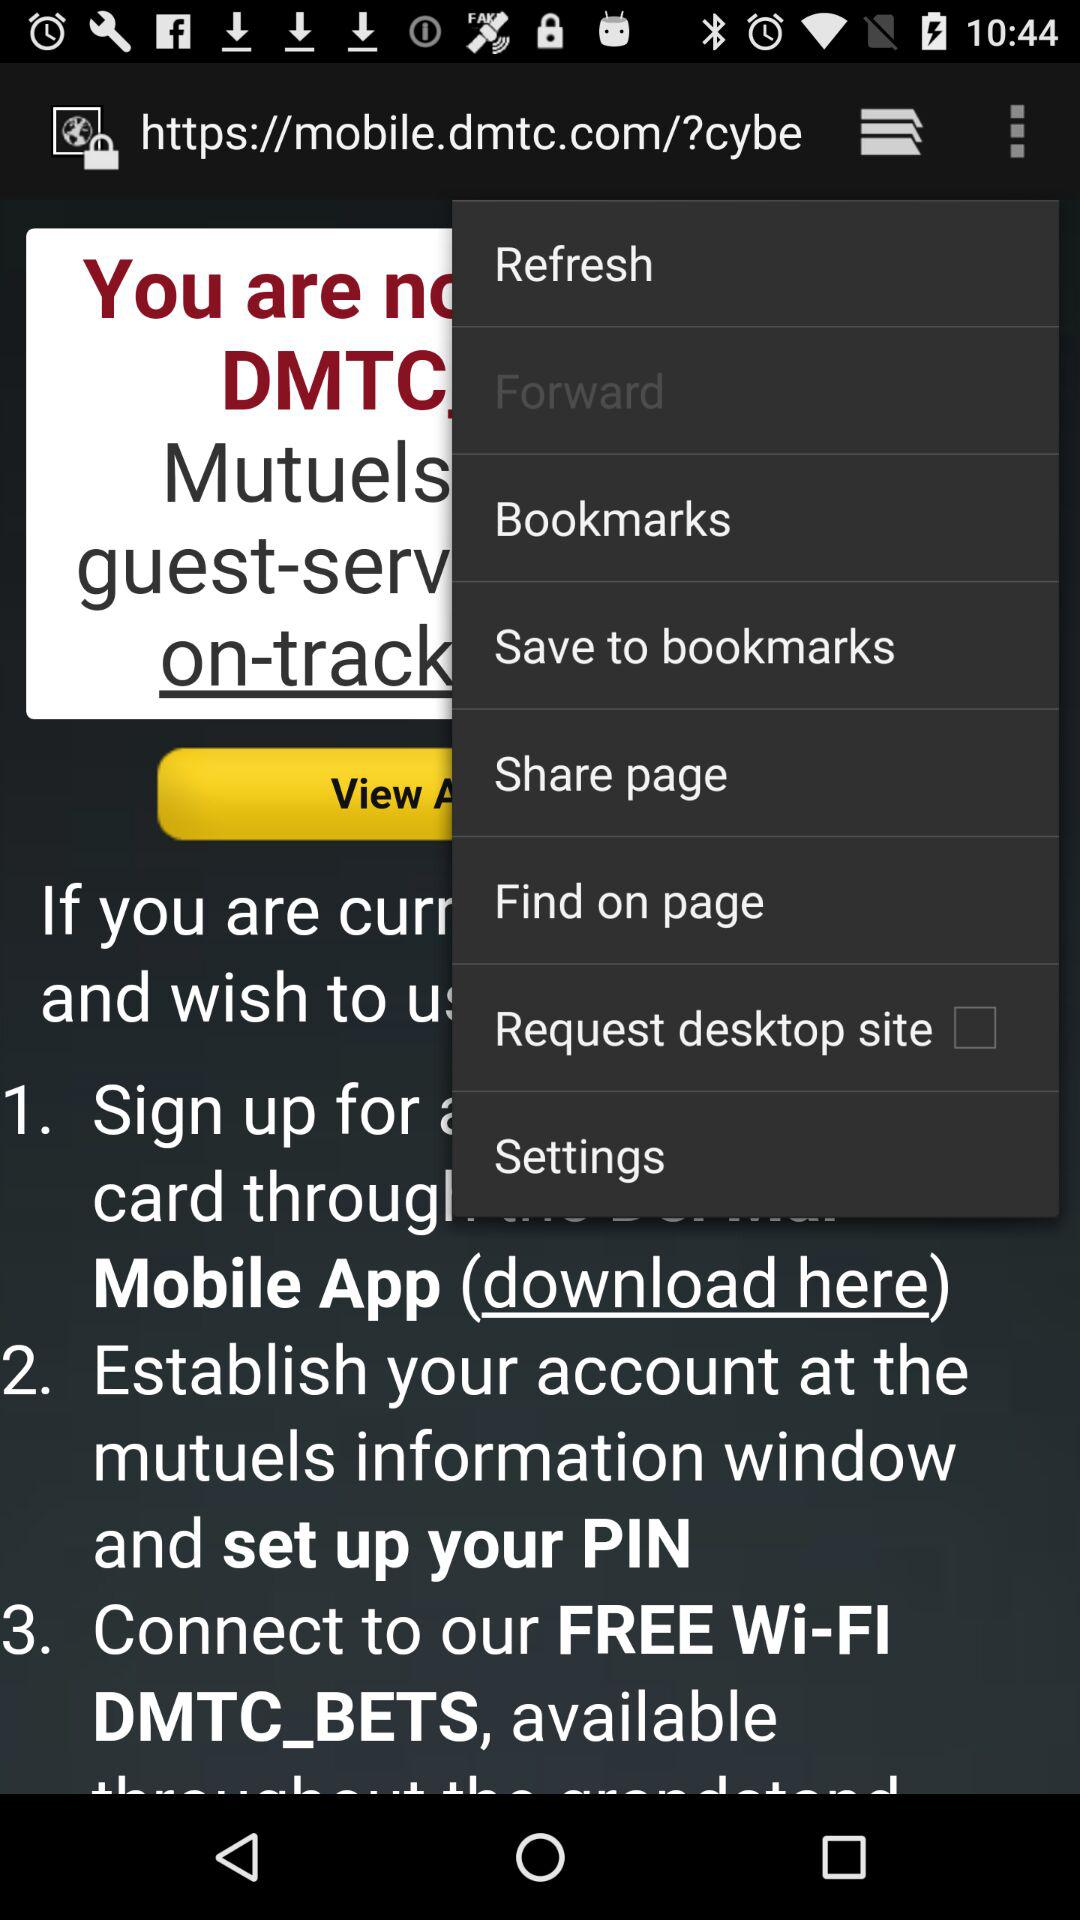What is the status of the request desktop site? The status is off. 